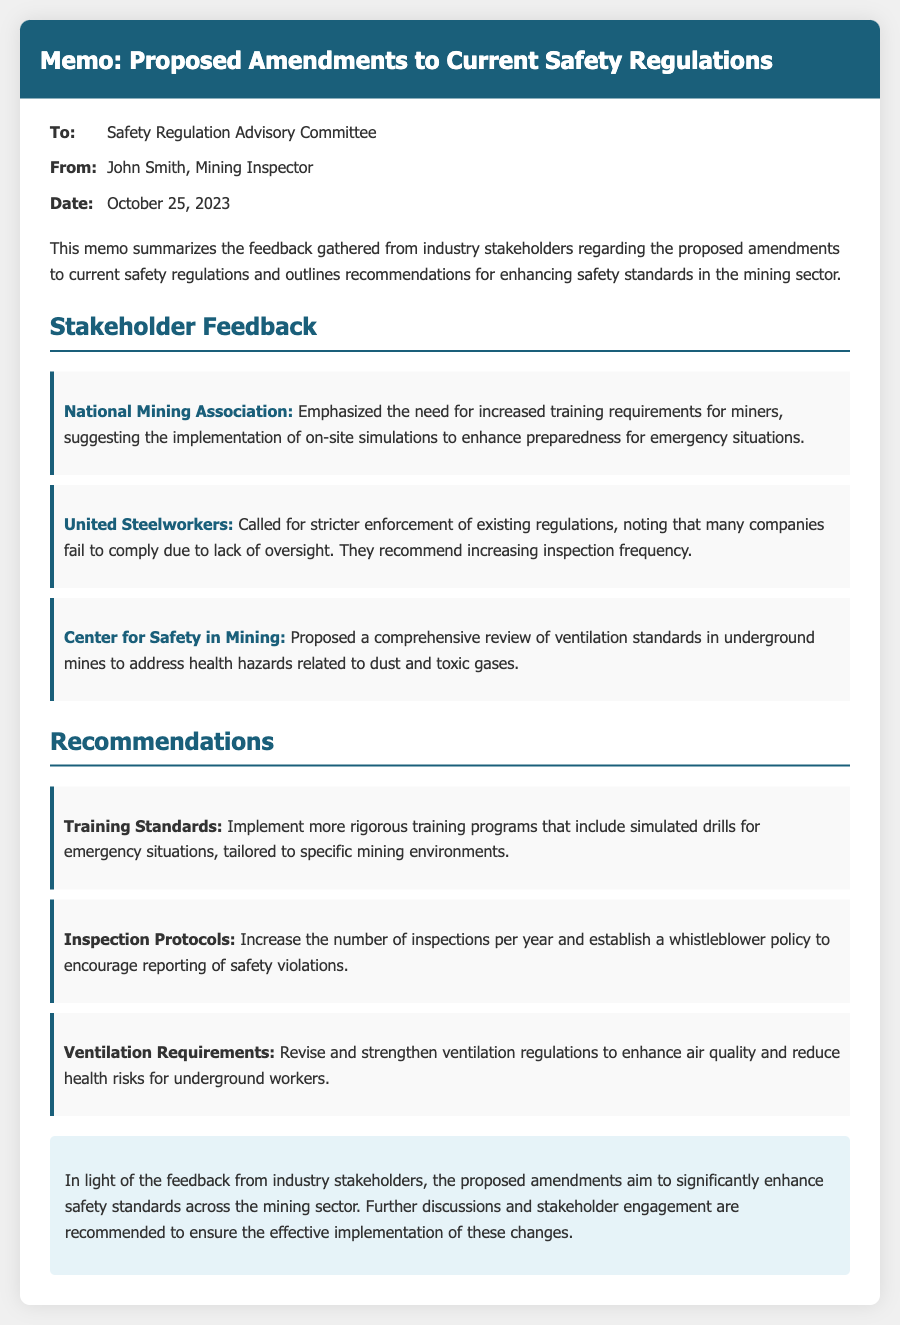What is the date of the memo? The date of the memo is stated in the document as October 25, 2023.
Answer: October 25, 2023 Who is the author of the memo? The memo indicates that it is from John Smith, Mining Inspector.
Answer: John Smith What organization emphasized the need for increased training requirements? The National Mining Association is the organization that provided this feedback.
Answer: National Mining Association How many recommendations are provided in the document? The document lists three recommendations for enhancing safety standards.
Answer: Three What does the Center for Safety in Mining propose to review? The Center for Safety in Mining proposes a comprehensive review of ventilation standards.
Answer: Ventilation standards What is one suggestion to enhance training standards? The document suggests implementing simulated drills for emergency situations.
Answer: Simulated drills What is the main focus of the recommendations section? The recommendations section focuses on enhancing safety standards in the mining sector.
Answer: Enhancing safety standards What policy is recommended to encourage reporting of safety violations? The document mentions establishing a whistleblower policy as part of the recommendations.
Answer: Whistleblower policy What is a conclusion made in the memo? The memo concludes that proposed amendments aim to enhance safety standards across the mining sector.
Answer: Enhance safety standards across the mining sector 